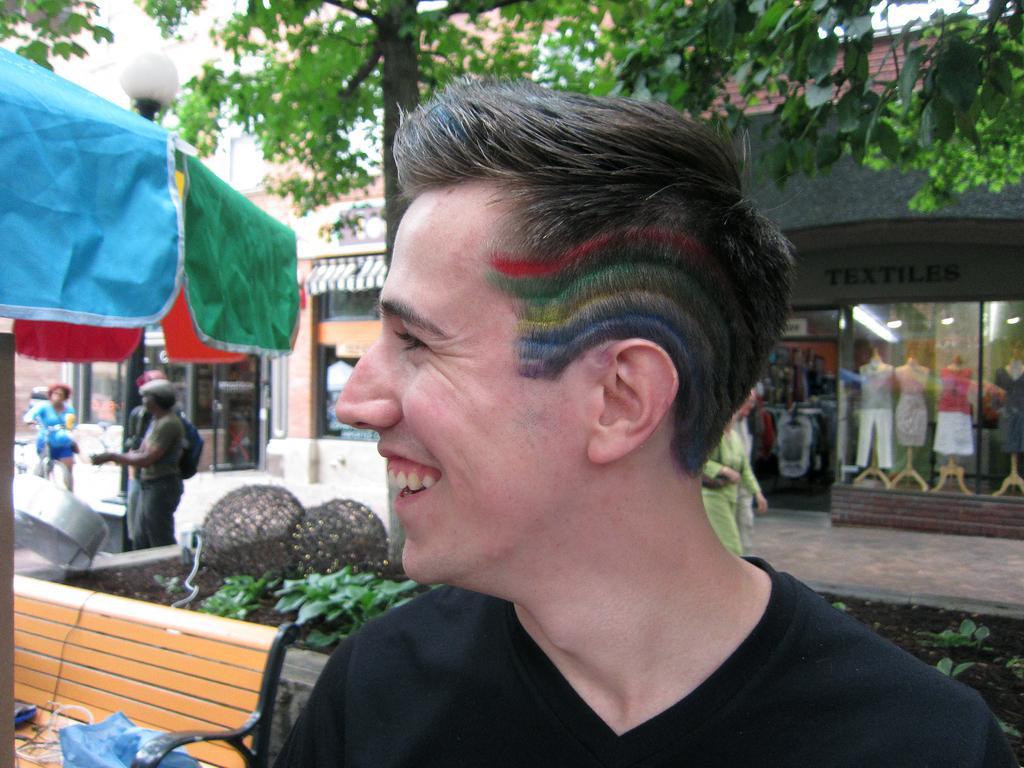How would you summarize this image in a sentence or two? In this picture I can see there is a man standing and he is wearing a black shirt, laughing and looking at left side. His hair is dyed with different colors like red, green, blue. On to left there is a umbrella, a bench, there are few people standing at the pole and there is another person. There are two persons walking to right and there are small plants on the floor and there is a tree and buildings in the backdrop. 